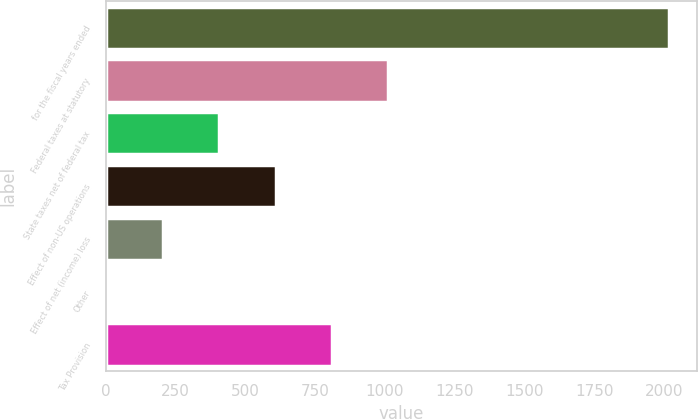<chart> <loc_0><loc_0><loc_500><loc_500><bar_chart><fcel>for the fiscal years ended<fcel>Federal taxes at statutory<fcel>State taxes net of federal tax<fcel>Effect of non-US operations<fcel>Effect of net (income) loss<fcel>Other<fcel>Tax Provision<nl><fcel>2017<fcel>1010.8<fcel>407.08<fcel>608.32<fcel>205.84<fcel>4.6<fcel>809.56<nl></chart> 